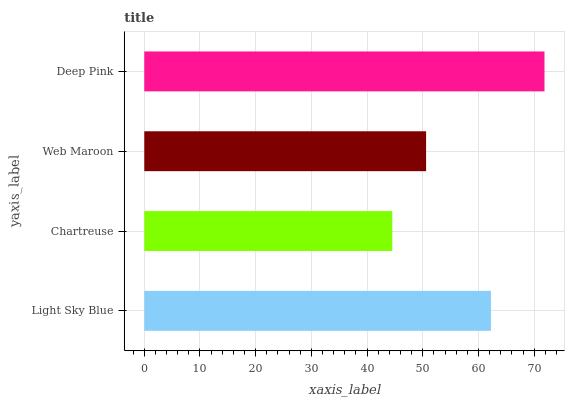Is Chartreuse the minimum?
Answer yes or no. Yes. Is Deep Pink the maximum?
Answer yes or no. Yes. Is Web Maroon the minimum?
Answer yes or no. No. Is Web Maroon the maximum?
Answer yes or no. No. Is Web Maroon greater than Chartreuse?
Answer yes or no. Yes. Is Chartreuse less than Web Maroon?
Answer yes or no. Yes. Is Chartreuse greater than Web Maroon?
Answer yes or no. No. Is Web Maroon less than Chartreuse?
Answer yes or no. No. Is Light Sky Blue the high median?
Answer yes or no. Yes. Is Web Maroon the low median?
Answer yes or no. Yes. Is Deep Pink the high median?
Answer yes or no. No. Is Chartreuse the low median?
Answer yes or no. No. 